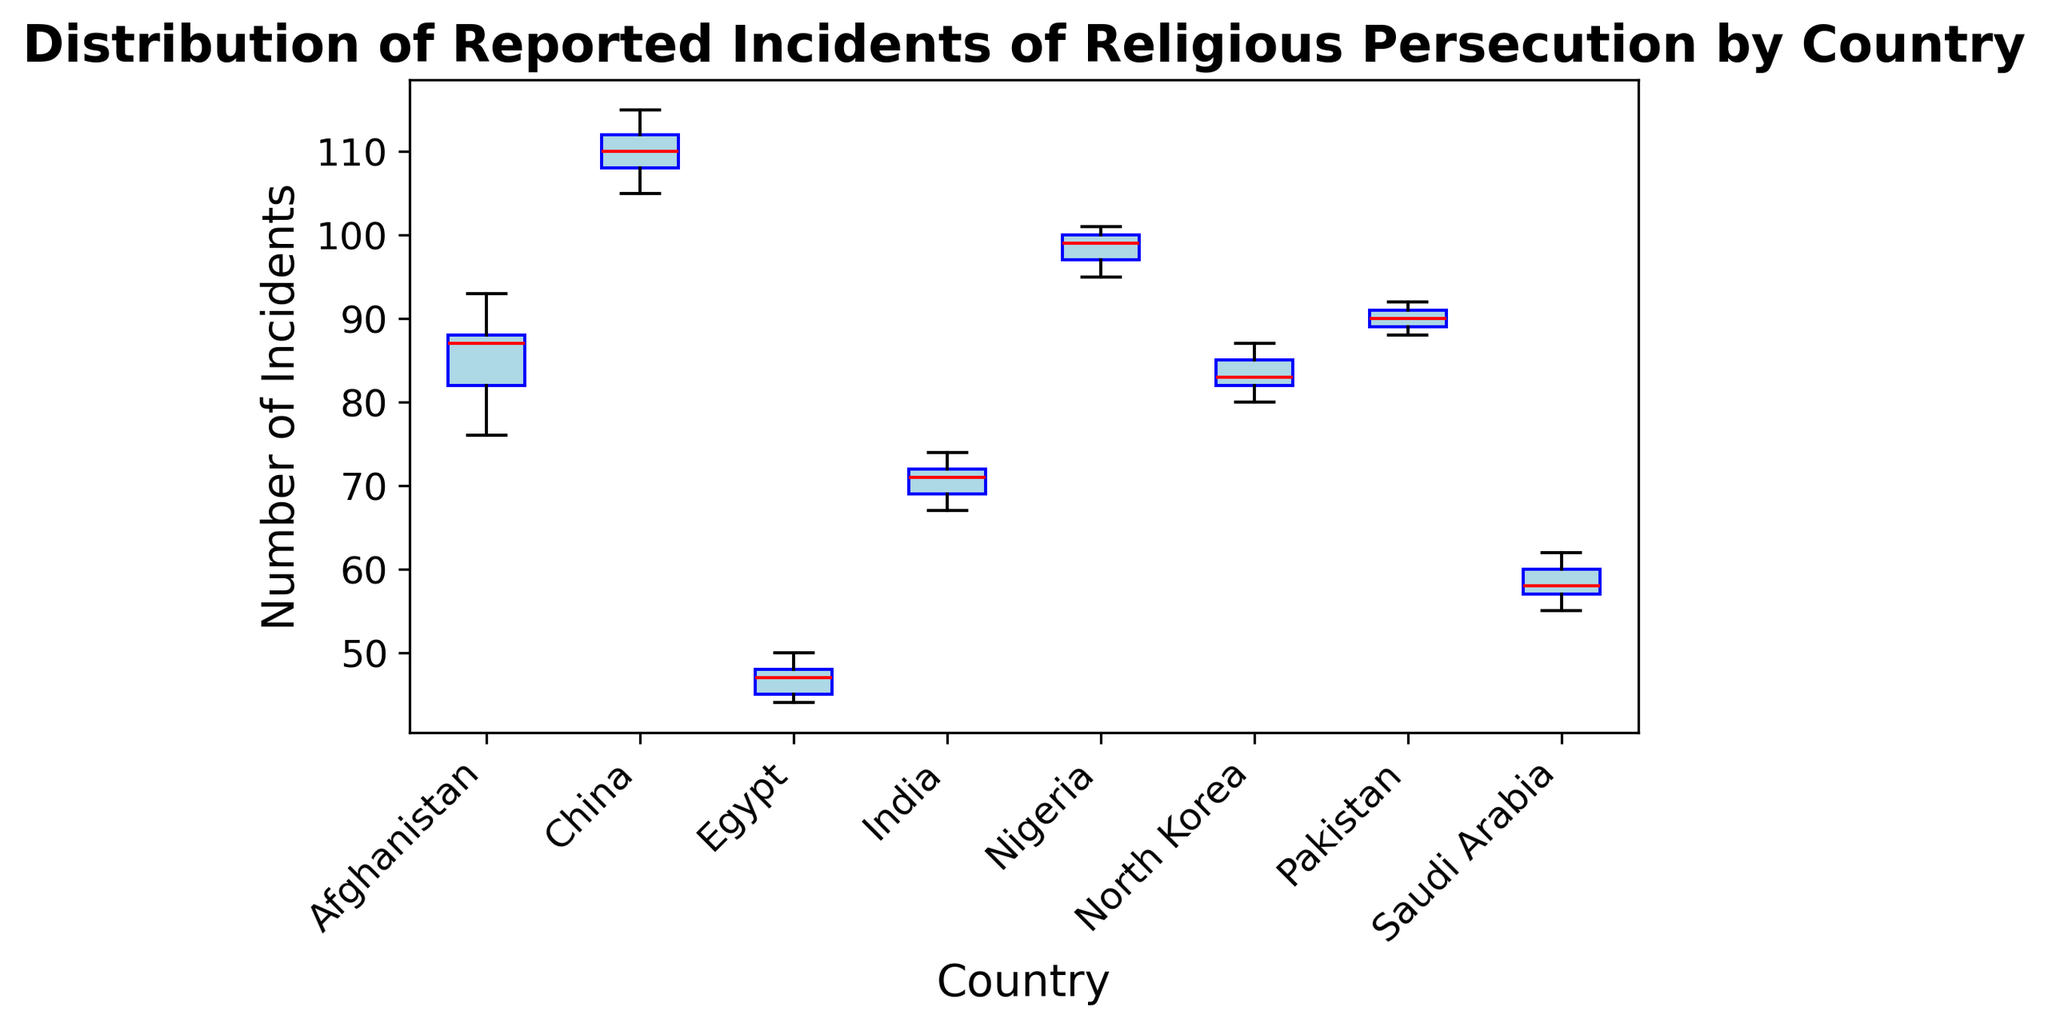What is the median number of incidents in Nigeria? Find Nigeria's box in the box plot. The red line inside the box represents the median value. Nigeria's median appears to be 99.
Answer: 99 Which country has the highest median number of incidents? Compare the red lines (medians) inside the boxes for each country. China's red line is the highest.
Answer: China What is the range of incidents reported in Egypt? Calculate the difference between the maximum and minimum whiskers of Egypt's box. The highest is 50 and the lowest is 44. Therefore, the range is 50 - 44 = 6.
Answer: 6 Which country has the lowest minimum number of incidents reported? Identify the lowest whisker across all boxes. Egypt has the lowest minimum at 44.
Answer: Egypt How do the medians of Afghanistan and Pakistan compare? Compare the red lines (medians) in the boxes for Afghanistan and Pakistan. Afghanistan's median is 87.5, while Pakistan's is 90. Therefore, Pakistan's median is higher.
Answer: Pakistan's median is higher What is the interquartile range (IQR) for incidents in India? The IQR is calculated by finding the difference between the third quartile (Q3) and the first quartile (Q1). In India's box, Q3 is roughly 72.5 and Q1 is about 69, so the IQR is 72.5 - 69 = 3.5.
Answer: 3.5 Which country has the widest interquartile range (IQR)? Find the boxes with the widest middle section (between Q1 and Q3). China has the widest IQR (115 - 105 = 10).
Answer: China Is there any overlap in the range of incidents between North Korea and Pakistan? Compare the whisker ranges of North Korea (80 to 87) and Pakistan (88 to 92). There is no overlap between these ranges.
Answer: No How do the distributions of incidents in Saudi Arabia and Egypt compare visually? Examine the shapes and spreads of Saudi Arabia's and Egypt's boxes. Both boxes have narrow ranges, but Saudi Arabia's incidents range from 55 to 62, whereas Egypt's incidents range from 44 to 50. Additionally, Egypt's median is lower.
Answer: Both are narrow; Saudi Arabia's values are higher Which country exhibits the most consistent number of incidents (least variability)? Look for the country with the smallest box and whisker range. Egypt has the smallest range of incidents, indicating the least variability.
Answer: Egypt 